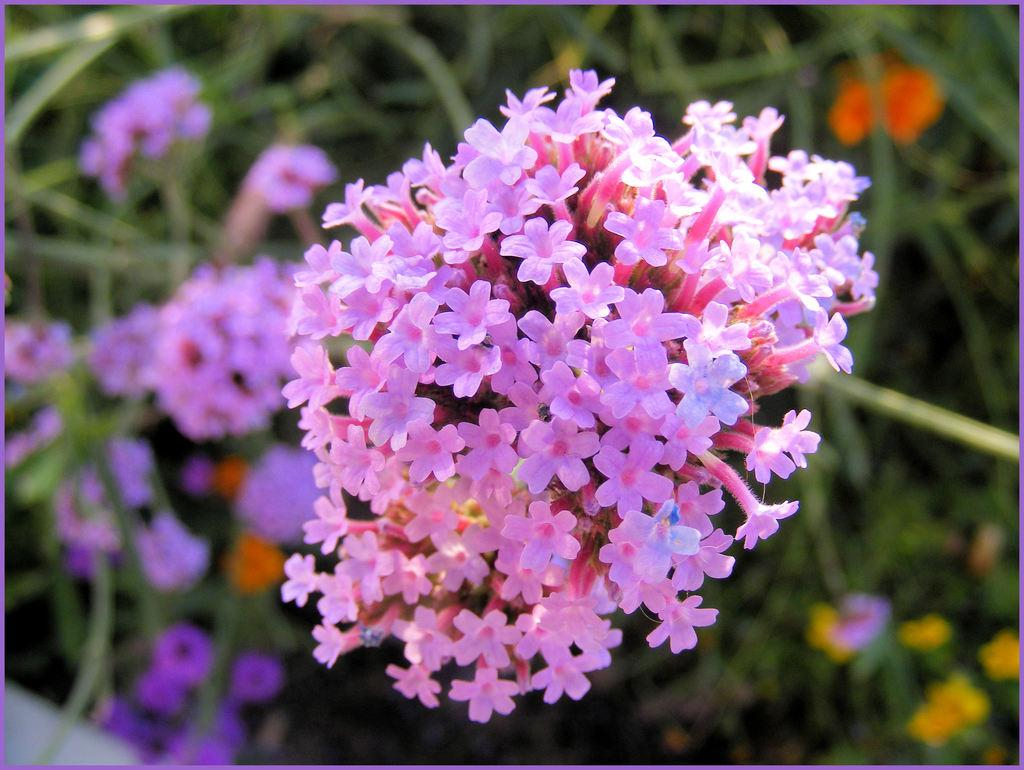What types of living organisms can be seen in the image? Plants and flowers are visible in the image. Can you describe the background of the image? The background of the image is blurred. What type of crime is being committed in the image? There is no indication of any crime being committed in the image; it features plants and flowers with a blurred background. How many planes can be seen in the image? There are no planes present in the image. 